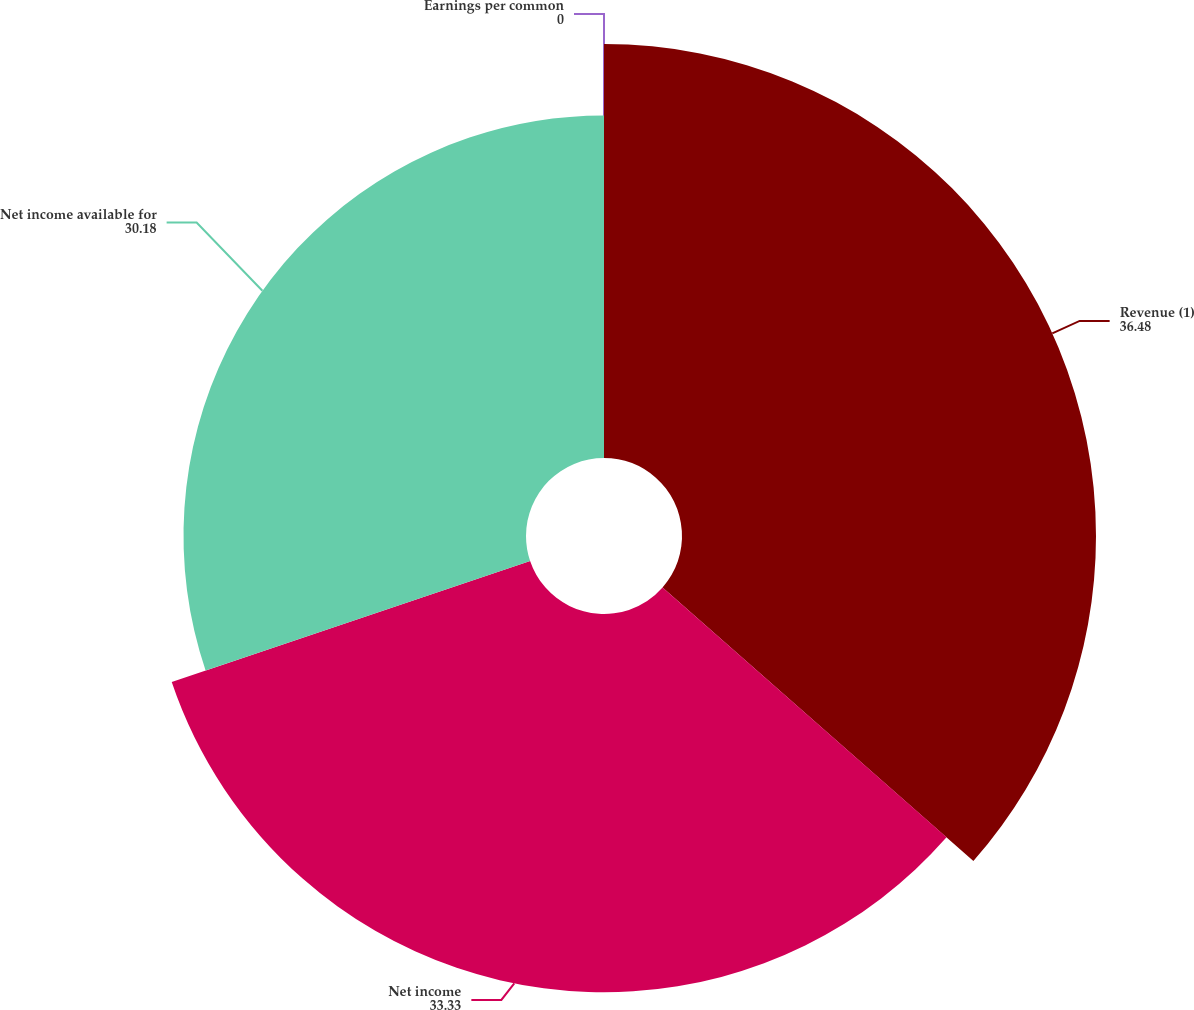<chart> <loc_0><loc_0><loc_500><loc_500><pie_chart><fcel>Revenue (1)<fcel>Net income<fcel>Net income available for<fcel>Earnings per common<nl><fcel>36.48%<fcel>33.33%<fcel>30.18%<fcel>0.0%<nl></chart> 